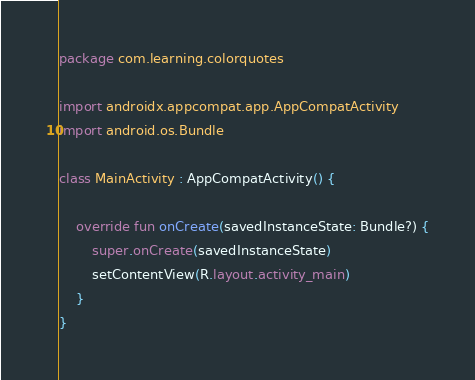Convert code to text. <code><loc_0><loc_0><loc_500><loc_500><_Kotlin_>package com.learning.colorquotes

import androidx.appcompat.app.AppCompatActivity
import android.os.Bundle

class MainActivity : AppCompatActivity() {

    override fun onCreate(savedInstanceState: Bundle?) {
        super.onCreate(savedInstanceState)
        setContentView(R.layout.activity_main)
    }
}
</code> 